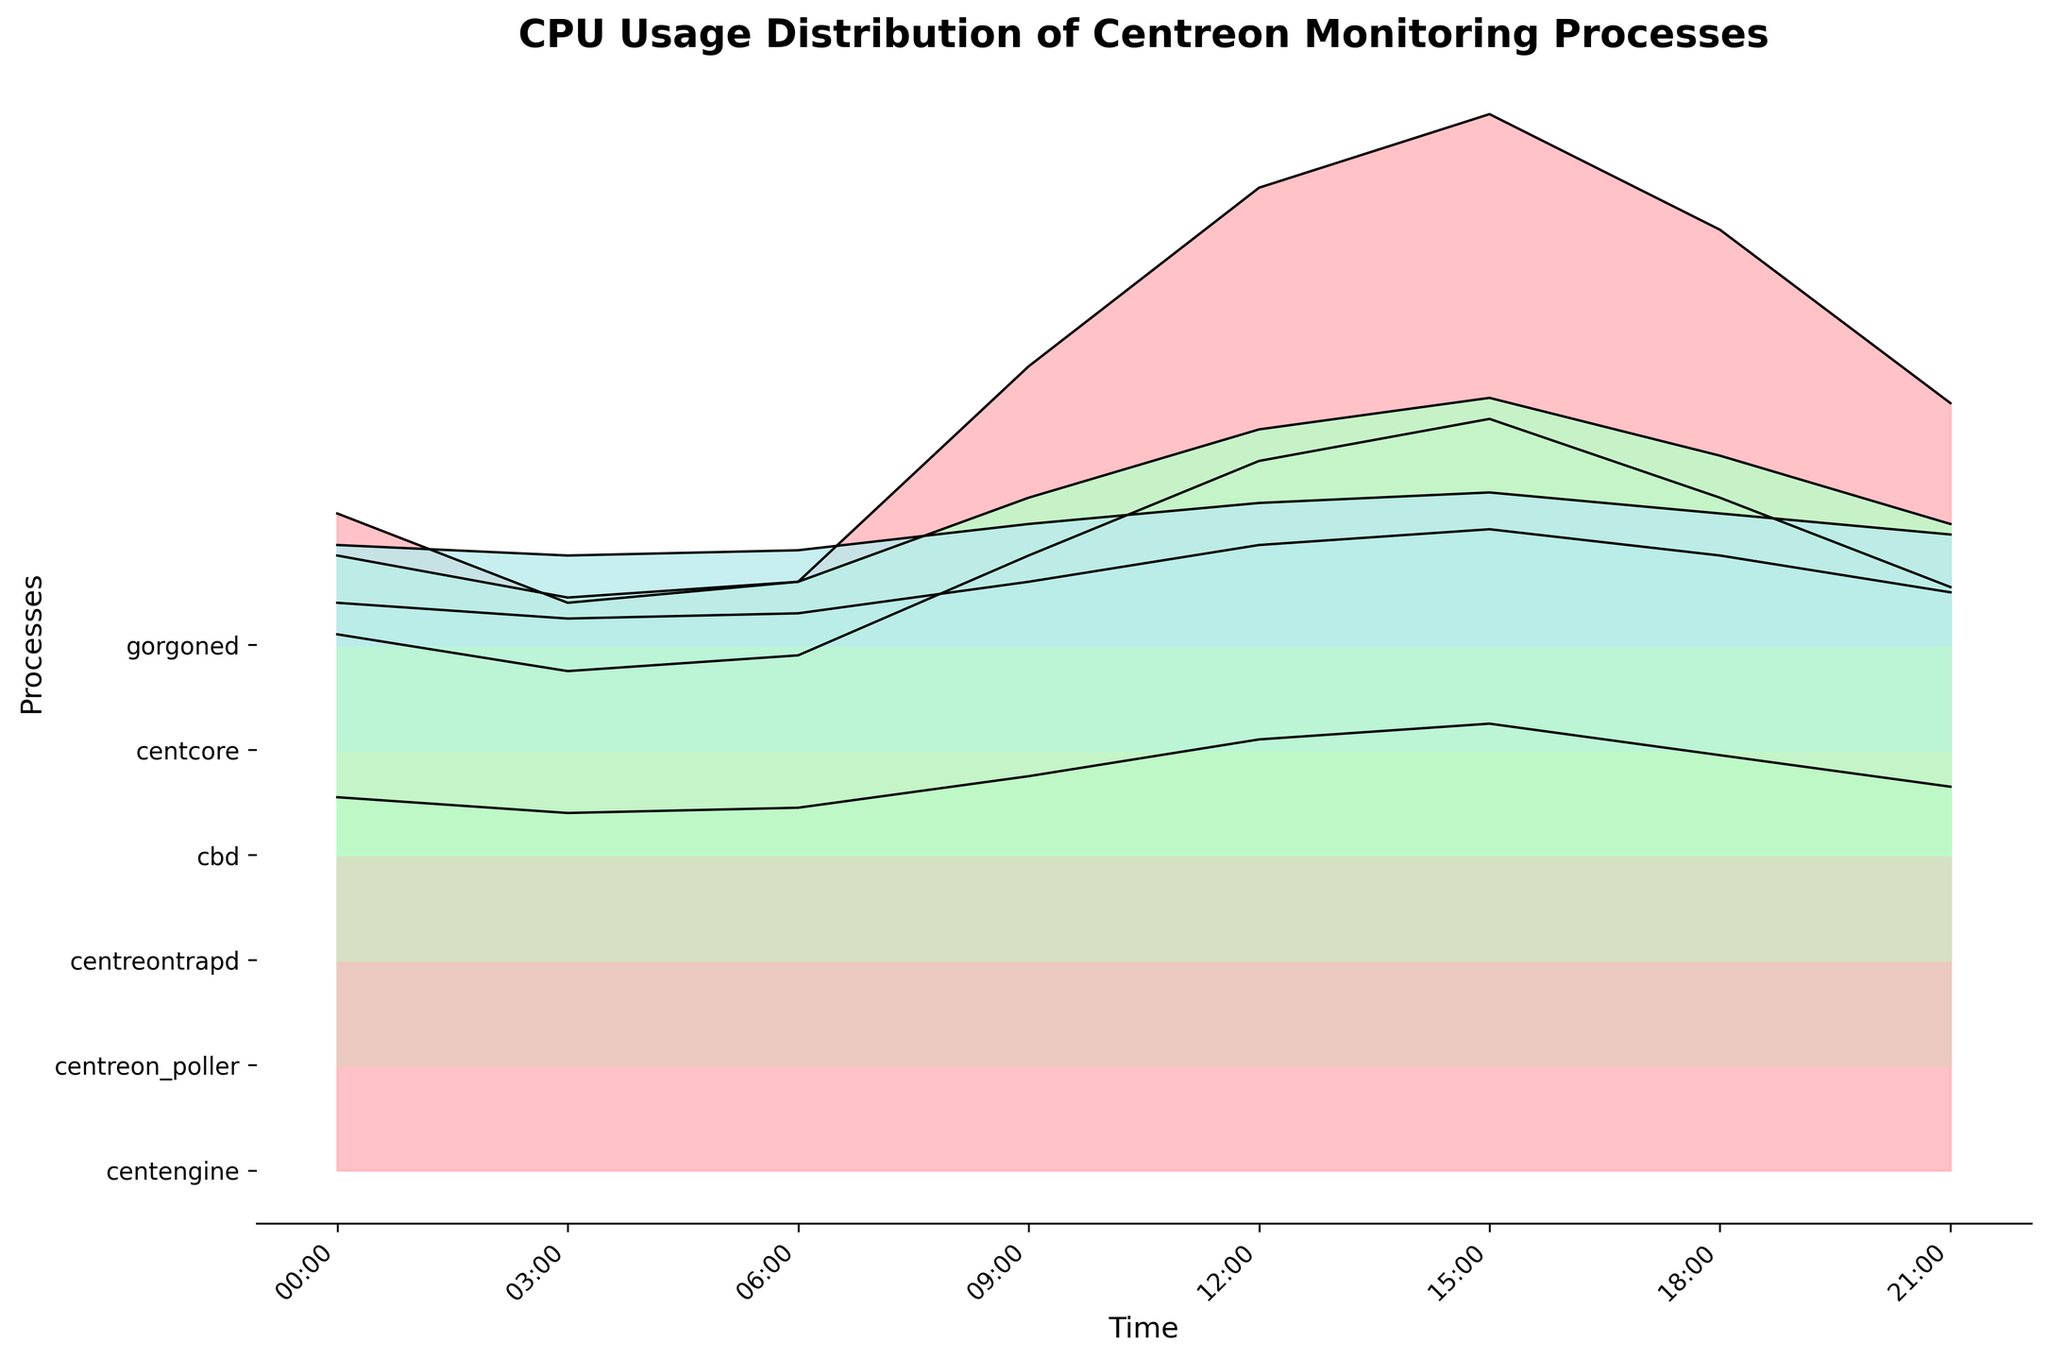What is the total number of processes displayed in the figure? The y-axis of the plot lists the names of the processes being monitored. Counting them gives the total number of processes displayed.
Answer: 6 What is the title of the figure? The title of the figure is usually displayed at the top of the plot for contextual information.
Answer: CPU Usage Distribution of Centreon Monitoring Processes Which process has the highest CPU usage at 15:00? Locate the x-axis tick for 15:00 and check the heights of the plots for each process at that time. The one with the highest peak represents the highest CPU usage.
Answer: centengine What is the average CPU usage of the `centreon_poller` process over the 24-hour period? Add the CPU usage values for `centreon_poller` at all the time points and divide by the total number of time points (8). (8.2 + 7.5 + 7.8 + 9.7 + 11.5 + 12.3 + 10.8 + 9.1) / 8 = 77.9 / 8
Answer: 9.74 How does the CPU usage of `cbd` at 00:00 compare to the usage at 18:00? Look at the height of the `cbd` plot at 00:00 and compare it to the height at 18:00.
Answer: Higher at 00:00 Which process shows a consistent increase in CPU usage throughout the day? Track the CPU usage for each process across all the time points; the process with monotonically increasing values shows a consistent increase.
Answer: centengine At what time is the CPU usage of `gorgoned` the lowest? Identify the time point where the `gorgoned` process has the smallest value on the y-axis.
Answer: 03:00 Which two processes have the smallest difference in CPU usage at 21:00? Compare the CPU usage values of all processes at 21:00 and find the two processes with the closest values.
Answer: centreontrapd and gorgoned How much higher is the CPU usage of `centcore` at 12:00 compared to 06:00? Subtract the CPU usage of `centcore` at 06:00 from its usage at 12:00. 3.9 - 2.6 = 1.3
Answer: 1.3 What can be inferred about the CPU usage trend of `centreontrapd`? Looking at the plot for `centreontrapd`, observe if the values form any recognizable trend, increasing, decreasing, or staying constant over time.
Answer: Slightly increasing trend 